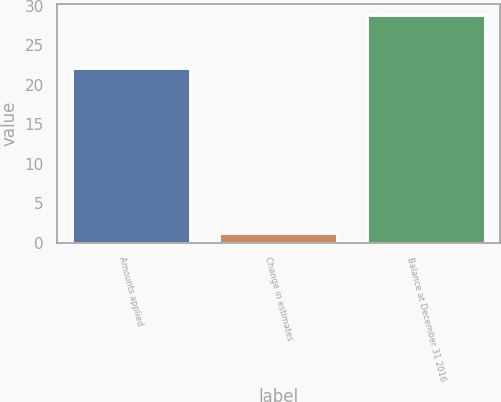Convert chart to OTSL. <chart><loc_0><loc_0><loc_500><loc_500><bar_chart><fcel>Amounts applied<fcel>Change in estimates<fcel>Balance at December 31 2016<nl><fcel>22.1<fcel>1.3<fcel>28.8<nl></chart> 